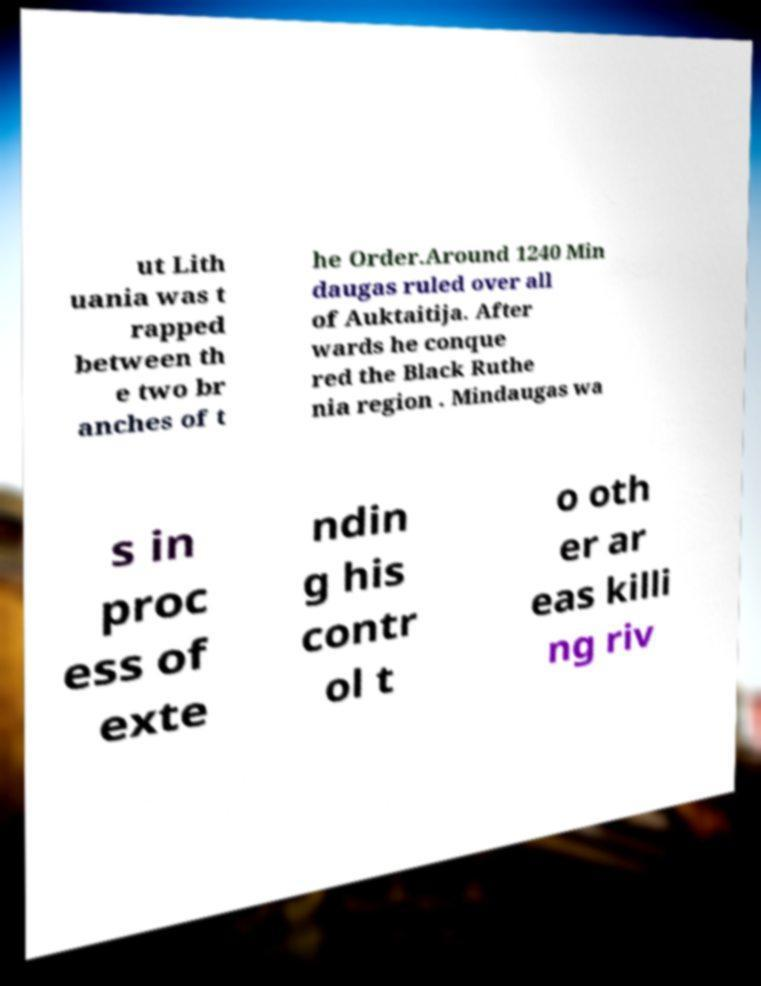What messages or text are displayed in this image? I need them in a readable, typed format. ut Lith uania was t rapped between th e two br anches of t he Order.Around 1240 Min daugas ruled over all of Auktaitija. After wards he conque red the Black Ruthe nia region . Mindaugas wa s in proc ess of exte ndin g his contr ol t o oth er ar eas killi ng riv 